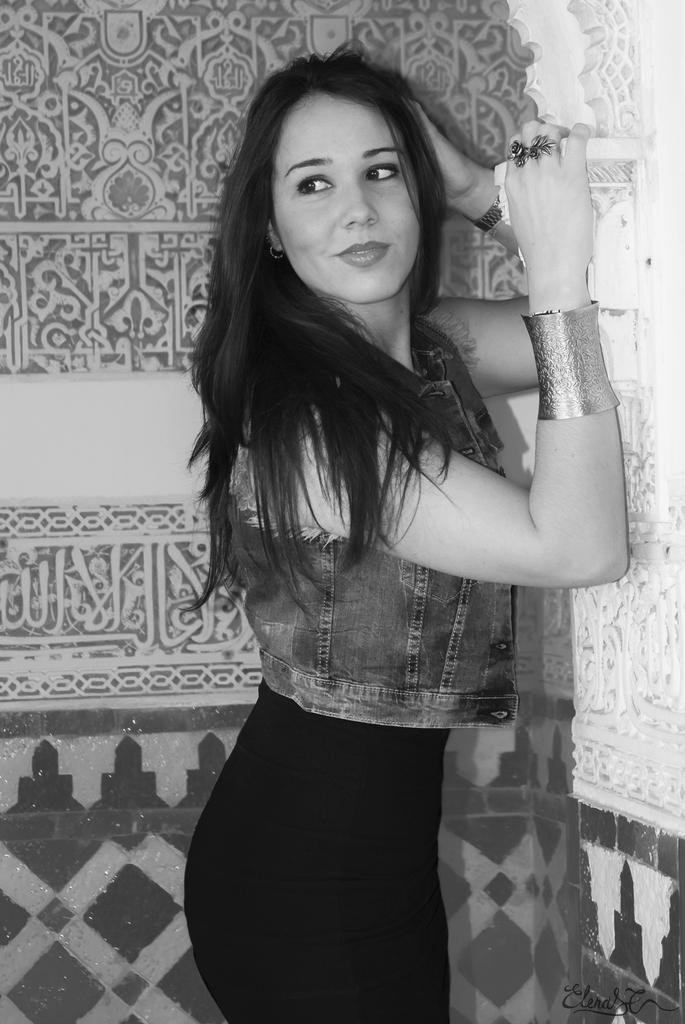Who is the main subject in the image? There is a woman in the picture. What jewelry is the woman wearing? The woman is wearing two rings on her fingers. Are there any other accessories visible on the woman? Yes, there is a brass hand band on the woman's right hand. What can be seen in the background of the image? There are designs on the wall in the background of the image. What type of potato is being used to create the scent in the image? There is no potato or scent present in the image; it features a woman wearing jewelry and accessories. 